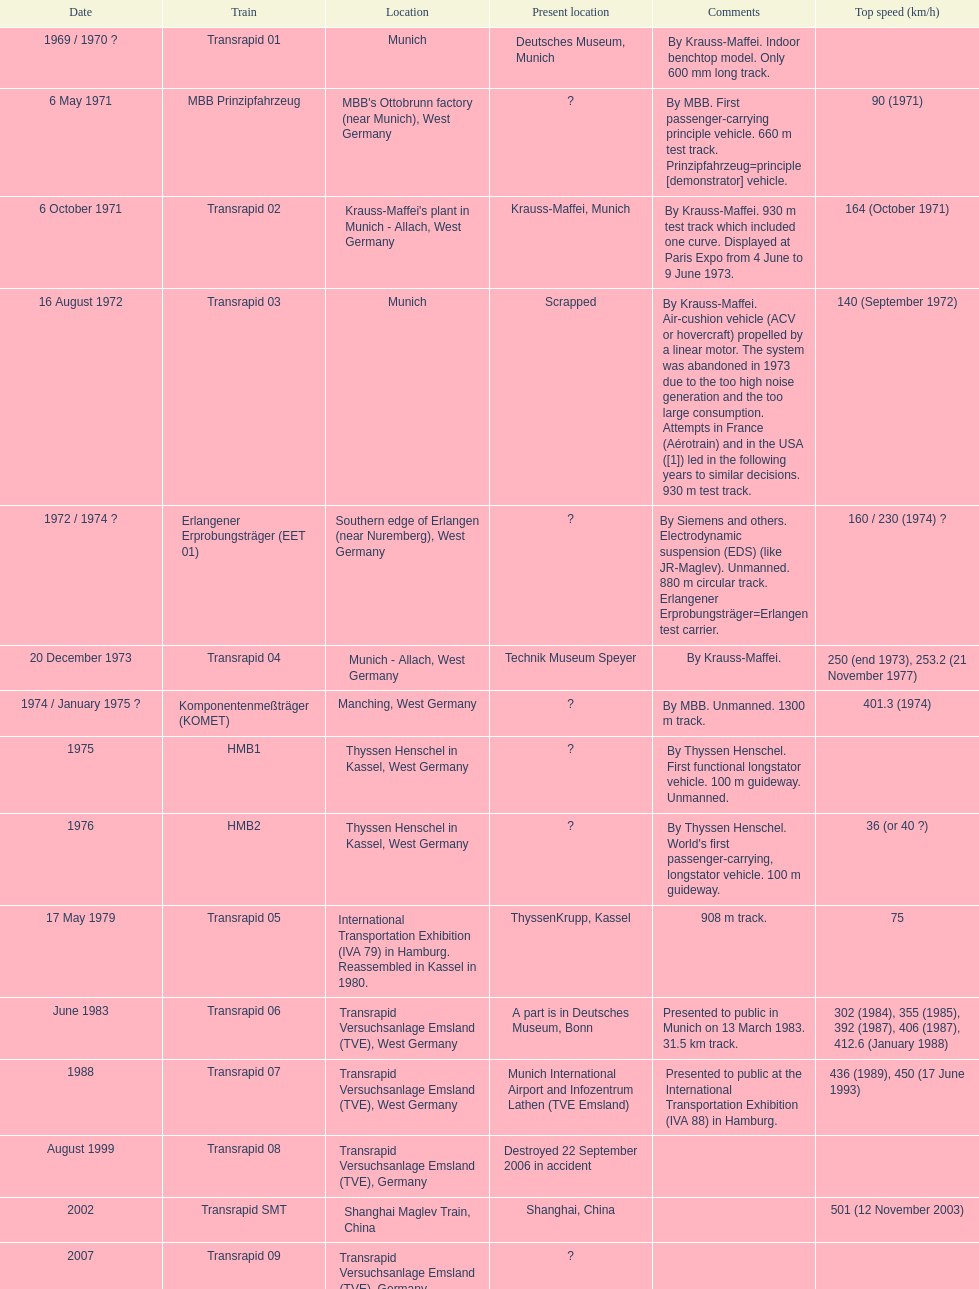What is the sole train to achieve a maximum speed of 500 or higher? Transrapid SMT. Help me parse the entirety of this table. {'header': ['Date', 'Train', 'Location', 'Present location', 'Comments', 'Top speed (km/h)'], 'rows': [['1969 / 1970\xa0?', 'Transrapid 01', 'Munich', 'Deutsches Museum, Munich', 'By Krauss-Maffei. Indoor benchtop model. Only 600\xa0mm long track.', ''], ['6 May 1971', 'MBB Prinzipfahrzeug', "MBB's Ottobrunn factory (near Munich), West Germany", '?', 'By MBB. First passenger-carrying principle vehicle. 660 m test track. Prinzipfahrzeug=principle [demonstrator] vehicle.', '90 (1971)'], ['6 October 1971', 'Transrapid 02', "Krauss-Maffei's plant in Munich - Allach, West Germany", 'Krauss-Maffei, Munich', 'By Krauss-Maffei. 930 m test track which included one curve. Displayed at Paris Expo from 4 June to 9 June 1973.', '164 (October 1971)'], ['16 August 1972', 'Transrapid 03', 'Munich', 'Scrapped', 'By Krauss-Maffei. Air-cushion vehicle (ACV or hovercraft) propelled by a linear motor. The system was abandoned in 1973 due to the too high noise generation and the too large consumption. Attempts in France (Aérotrain) and in the USA ([1]) led in the following years to similar decisions. 930 m test track.', '140 (September 1972)'], ['1972 / 1974\xa0?', 'Erlangener Erprobungsträger (EET 01)', 'Southern edge of Erlangen (near Nuremberg), West Germany', '?', 'By Siemens and others. Electrodynamic suspension (EDS) (like JR-Maglev). Unmanned. 880 m circular track. Erlangener Erprobungsträger=Erlangen test carrier.', '160 / 230 (1974)\xa0?'], ['20 December 1973', 'Transrapid 04', 'Munich - Allach, West Germany', 'Technik Museum Speyer', 'By Krauss-Maffei.', '250 (end 1973), 253.2 (21 November 1977)'], ['1974 / January 1975\xa0?', 'Komponentenmeßträger (KOMET)', 'Manching, West Germany', '?', 'By MBB. Unmanned. 1300 m track.', '401.3 (1974)'], ['1975', 'HMB1', 'Thyssen Henschel in Kassel, West Germany', '?', 'By Thyssen Henschel. First functional longstator vehicle. 100 m guideway. Unmanned.', ''], ['1976', 'HMB2', 'Thyssen Henschel in Kassel, West Germany', '?', "By Thyssen Henschel. World's first passenger-carrying, longstator vehicle. 100 m guideway.", '36 (or 40\xa0?)'], ['17 May 1979', 'Transrapid 05', 'International Transportation Exhibition (IVA 79) in Hamburg. Reassembled in Kassel in 1980.', 'ThyssenKrupp, Kassel', '908 m track.', '75'], ['June 1983', 'Transrapid 06', 'Transrapid Versuchsanlage Emsland (TVE), West Germany', 'A part is in Deutsches Museum, Bonn', 'Presented to public in Munich on 13 March 1983. 31.5\xa0km track.', '302 (1984), 355 (1985), 392 (1987), 406 (1987), 412.6 (January 1988)'], ['1988', 'Transrapid 07', 'Transrapid Versuchsanlage Emsland (TVE), West Germany', 'Munich International Airport and Infozentrum Lathen (TVE Emsland)', 'Presented to public at the International Transportation Exhibition (IVA 88) in Hamburg.', '436 (1989), 450 (17 June 1993)'], ['August 1999', 'Transrapid 08', 'Transrapid Versuchsanlage Emsland (TVE), Germany', 'Destroyed 22 September 2006 in accident', '', ''], ['2002', 'Transrapid SMT', 'Shanghai Maglev Train, China', 'Shanghai, China', '', '501 (12 November 2003)'], ['2007', 'Transrapid 09', 'Transrapid Versuchsanlage Emsland (TVE), Germany', '?', '', '']]} 